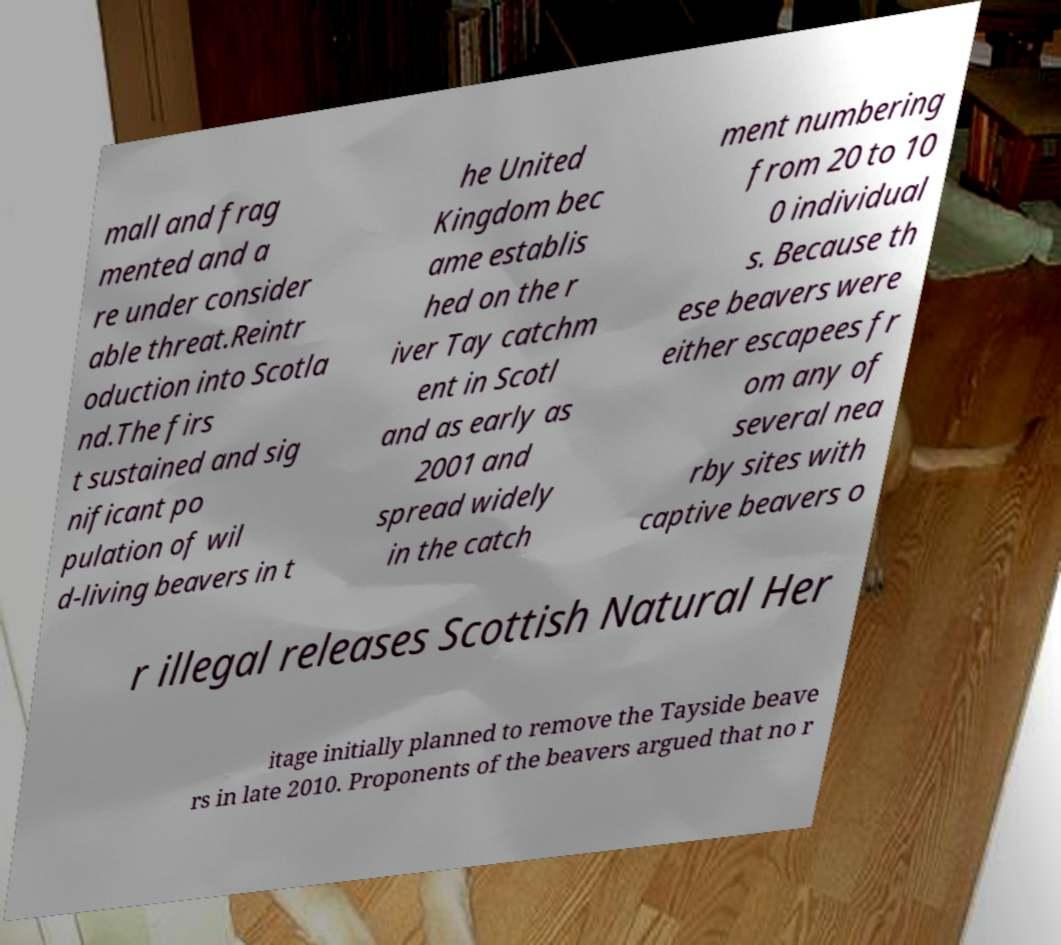I need the written content from this picture converted into text. Can you do that? mall and frag mented and a re under consider able threat.Reintr oduction into Scotla nd.The firs t sustained and sig nificant po pulation of wil d-living beavers in t he United Kingdom bec ame establis hed on the r iver Tay catchm ent in Scotl and as early as 2001 and spread widely in the catch ment numbering from 20 to 10 0 individual s. Because th ese beavers were either escapees fr om any of several nea rby sites with captive beavers o r illegal releases Scottish Natural Her itage initially planned to remove the Tayside beave rs in late 2010. Proponents of the beavers argued that no r 